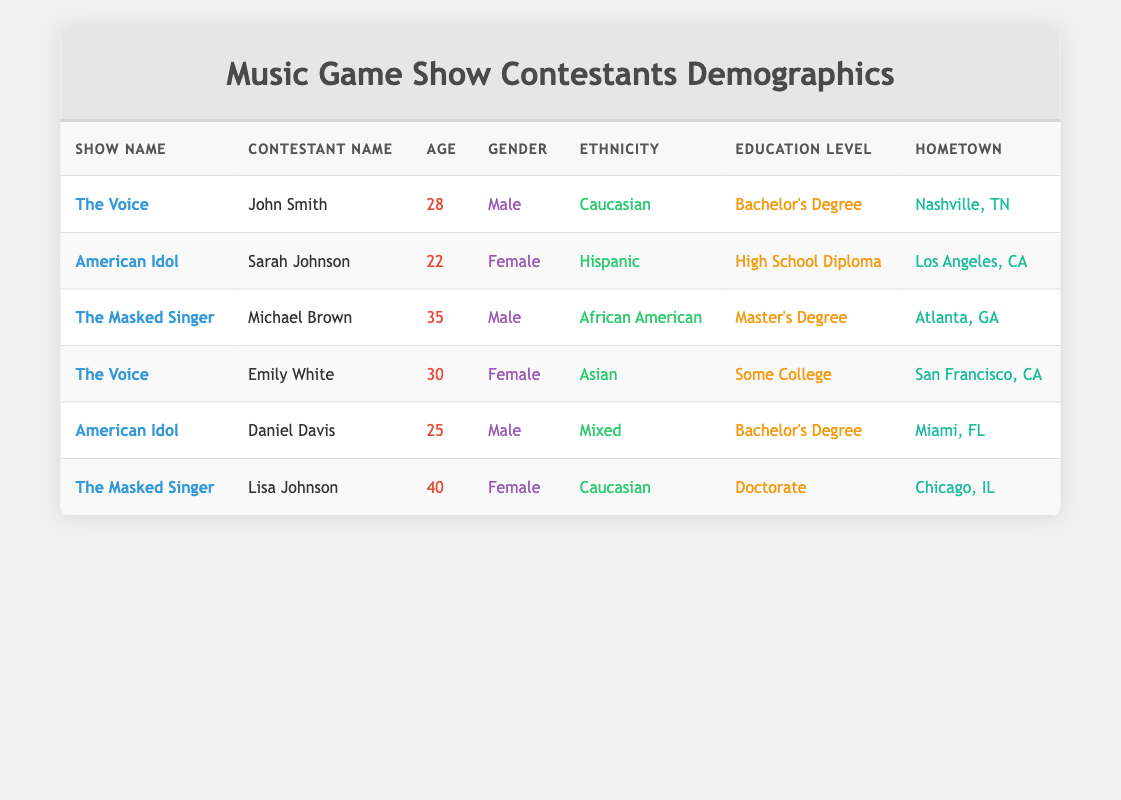What is the age of Sarah Johnson? Sarah Johnson is listed in the table under American Idol, and her age is specifically stated as 22.
Answer: 22 Which contestant has the highest age? Michael Brown is 35 years old, which is the highest age among the contestants listed in the table. Other ages (28, 22, 30, 25, and 40) are lower than his.
Answer: Michael Brown (35) How many contestants are female? There are three female contestants: Sarah Johnson, Emily White, and Lisa Johnson. The total count of females is determined by reviewing the gender column for any entries marked as Female.
Answer: 3 Is Daniel Davis a contestant on The Voice? Daniel Davis is listed under American Idol and not The Voice. In the table, his show is specifically stated, confirming he is associated with American Idol.
Answer: No What is the average age of contestants from The Voice? There are two contestants from The Voice: John Smith (28) and Emily White (30). The sum of their ages is 28 + 30 = 58. Dividing by 2 gives an average age of 29.
Answer: 29 How many contestants have a Bachelor's Degree? Two contestants, John Smith and Daniel Davis, have a Bachelor's Degree. This is verified by checking the education level for each contestant and counting instances of Bachelor's Degree.
Answer: 2 Is Lisa Johnson's hometown in Texas? Lisa Johnson's hometown is listed as Chicago, IL. Since Chicago is in Illinois, the statement is false.
Answer: No What is the most common ethnicity among the contestants? The ethnicities listed are Caucasian, Hispanic, African American, Asian, and Mixed. There are two Caucasian contestants (John Smith and Lisa Johnson) and others with one each. Therefore, Caucasian is the most common ethnicity.
Answer: Caucasian 